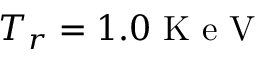<formula> <loc_0><loc_0><loc_500><loc_500>T _ { r } = 1 . 0 K e V</formula> 